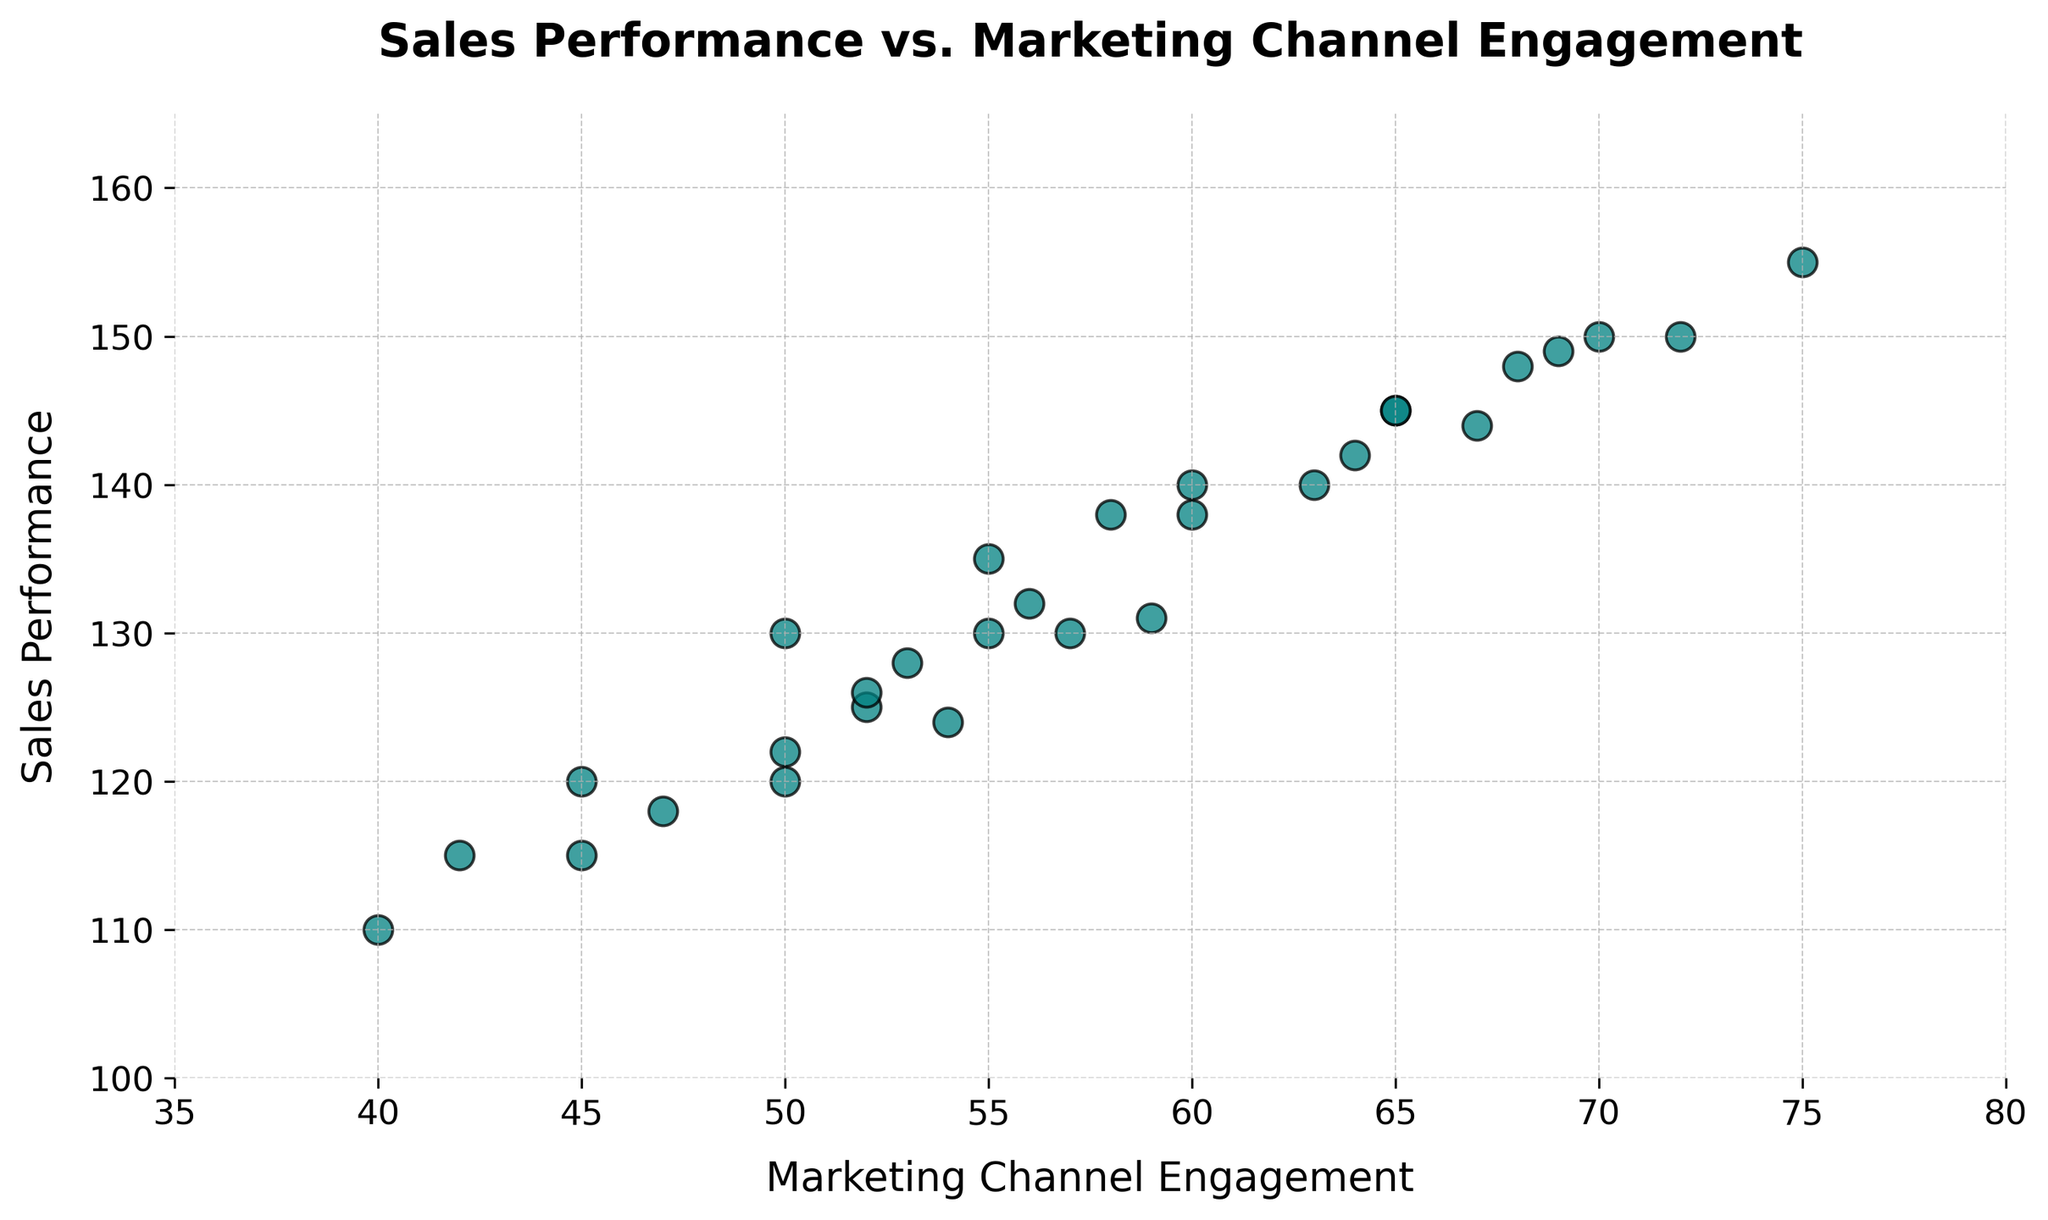What is the trend between Marketing Channel Engagement and Sales Performance? The scatter plot shows an upward trend; as Marketing Channel Engagement increases, Sales Performance also tends to increase.
Answer: Positive trend Which data point has the highest Sales Performance? By visually inspecting the y-axis, the highest Sales Performance value is around 155, corresponding to a Marketing Channel Engagement value of 75.
Answer: 155 Is there a data point with a Sales Performance of 110? If so, what is the Marketing Channel Engagement for that point? By checking the scatter points on the y-axis at 110, there is one point with a Marketing Channel Engagement of 40.
Answer: 40 Which two days have the same Marketing Channel Engagement but different Sales Performance? On inspecting the scatter plot, two points with Marketing Channel Engagement at 50 have different Sales Performances: one at 130 and one at 122.
Answer: 130 and 122 What is the average of the highest and lowest Sales Performance values, and which data points do they correspond to? The highest Sales Performance is 155, and the lowest is 110. The average is (155 + 110) / 2 = 132.5. These correspond to Marketing Channel Engagements of 75 (highest) and 40 (lowest).
Answer: 132.5 Which Marketing Channel Engagement has the most consistent Sales Performance values around it? By inspecting the x-axis, the Marketing Channel Engagement value of 50 has points clustered around it, showing consistent Sales Performance values (118, 122, and 130).
Answer: 50 What is the difference in Sales Performance between the highest and lowest data points in terms of Marketing Channel Engagement? The highest Marketing Channel Engagement is 75 with a Sales Performance of 155, and the lowest is 40 with a Sales Performance of 110. The difference is 155 - 110 = 45.
Answer: 45 How many data points exceed a Sales Performance of 140? By counting the scatter points above the 140 mark on the y-axis, there are 10 data points.
Answer: 10 Is there any point with the same value for both Sales Performance and Marketing Channel Engagement? By inspecting the scatter plot, no point on the figure shows the same value for both x (Marketing Channel Engagement) and y (Sales Performance).
Answer: No 